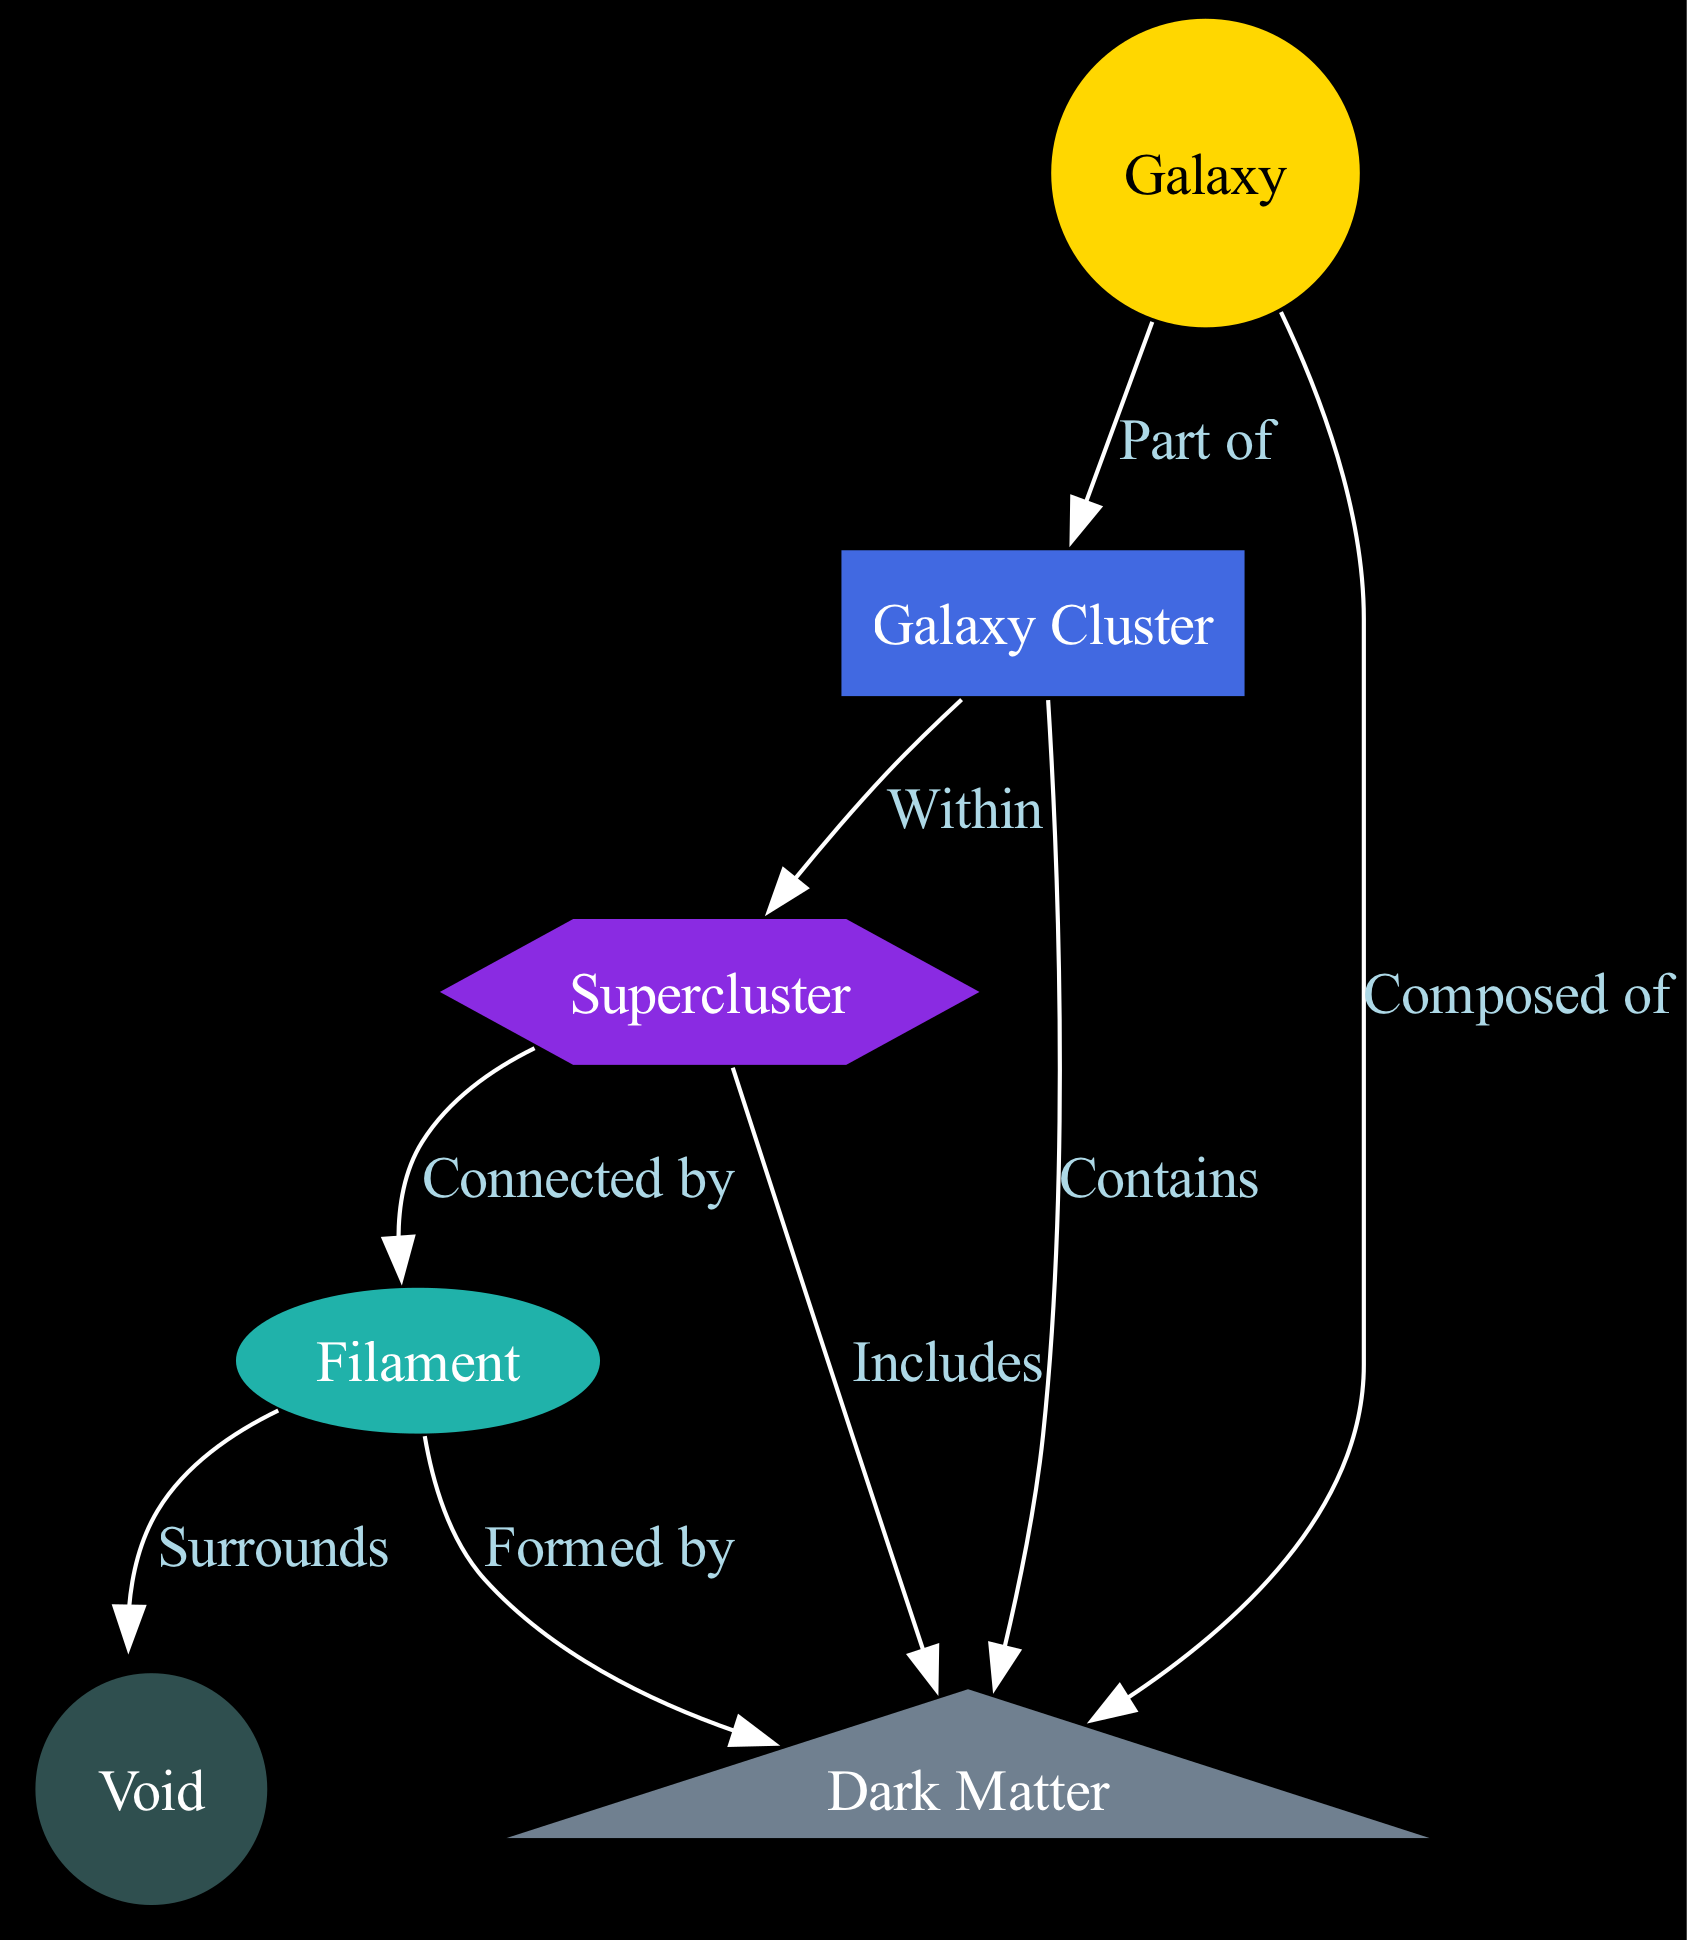What is the highest structure represented in the diagram? The highest structure in the diagram is the "Supercluster", as indicated by its placement among the other structures and its connection to "Galaxy Cluster" and "Filament".
Answer: Supercluster How many types of nodes are present in the diagram? By counting the unique labels in the nodes section, we see there are six types: Galaxy, Galaxy Cluster, Supercluster, Filament, Void, and Dark Matter.
Answer: 6 Which type of node is surrounded by "Filament"? The "Void" is directly connected to "Filament" with an edge labeled "Surrounds", indicating that voids are surrounded by filament structures.
Answer: Void What relationship do "Galaxy" and "Dark Matter" have? The edge labeled "Composed of" connects "Galaxy" to "Dark Matter", indicating that galaxies are made up of dark matter.
Answer: Composed of What surrounds the "Filament"? The "Void" surrounds the "Filament", as indicated by the connection labeled "Surrounds" in the diagram, providing insights into the spatial arrangement of these cosmic structures.
Answer: Void How is "Dark Matter" related to "Galaxy Cluster"? The relationship is expressed through the edge labeled "Contains", which shows that galaxy clusters include dark matter in their composition.
Answer: Contains What is the function of the "Supercluster" in the cosmic web? The "Supercluster" acts as a large structure that connects various "Galaxy Clusters" and "Filaments", representing a high-level organization in the distribution of galaxies.
Answer: Connects How many edges are there in total within the diagram? Counting the entries in the edges section, there are eight edges that represent different relationships between the nodes.
Answer: 8 Which structure is primarily described as thread-like? The "Filament" is described as a massive, thread-like structure, connecting different clusters and composed of dark matter, as indicated in the nodes' description.
Answer: Filament 